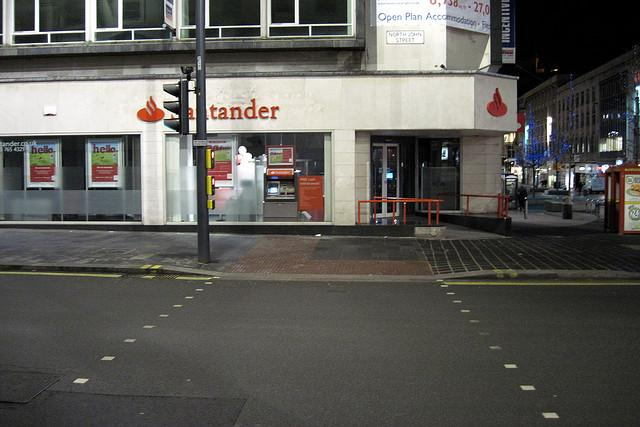What might come from the right or left at any time? traffic 